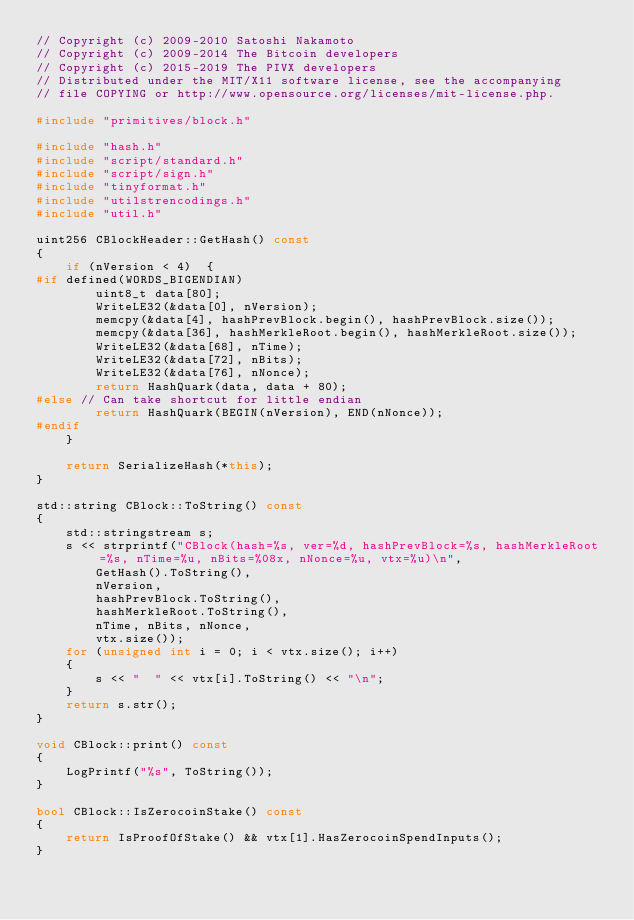Convert code to text. <code><loc_0><loc_0><loc_500><loc_500><_C++_>// Copyright (c) 2009-2010 Satoshi Nakamoto
// Copyright (c) 2009-2014 The Bitcoin developers
// Copyright (c) 2015-2019 The PIVX developers
// Distributed under the MIT/X11 software license, see the accompanying
// file COPYING or http://www.opensource.org/licenses/mit-license.php.

#include "primitives/block.h"

#include "hash.h"
#include "script/standard.h"
#include "script/sign.h"
#include "tinyformat.h"
#include "utilstrencodings.h"
#include "util.h"

uint256 CBlockHeader::GetHash() const
{
    if (nVersion < 4)  {
#if defined(WORDS_BIGENDIAN)
        uint8_t data[80];
        WriteLE32(&data[0], nVersion);
        memcpy(&data[4], hashPrevBlock.begin(), hashPrevBlock.size());
        memcpy(&data[36], hashMerkleRoot.begin(), hashMerkleRoot.size());
        WriteLE32(&data[68], nTime);
        WriteLE32(&data[72], nBits);
        WriteLE32(&data[76], nNonce);
        return HashQuark(data, data + 80);
#else // Can take shortcut for little endian
        return HashQuark(BEGIN(nVersion), END(nNonce));
#endif
    }

    return SerializeHash(*this);
}

std::string CBlock::ToString() const
{
    std::stringstream s;
    s << strprintf("CBlock(hash=%s, ver=%d, hashPrevBlock=%s, hashMerkleRoot=%s, nTime=%u, nBits=%08x, nNonce=%u, vtx=%u)\n",
        GetHash().ToString(),
        nVersion,
        hashPrevBlock.ToString(),
        hashMerkleRoot.ToString(),
        nTime, nBits, nNonce,
        vtx.size());
    for (unsigned int i = 0; i < vtx.size(); i++)
    {
        s << "  " << vtx[i].ToString() << "\n";
    }
    return s.str();
}

void CBlock::print() const
{
    LogPrintf("%s", ToString());
}

bool CBlock::IsZerocoinStake() const
{
    return IsProofOfStake() && vtx[1].HasZerocoinSpendInputs();
}
</code> 